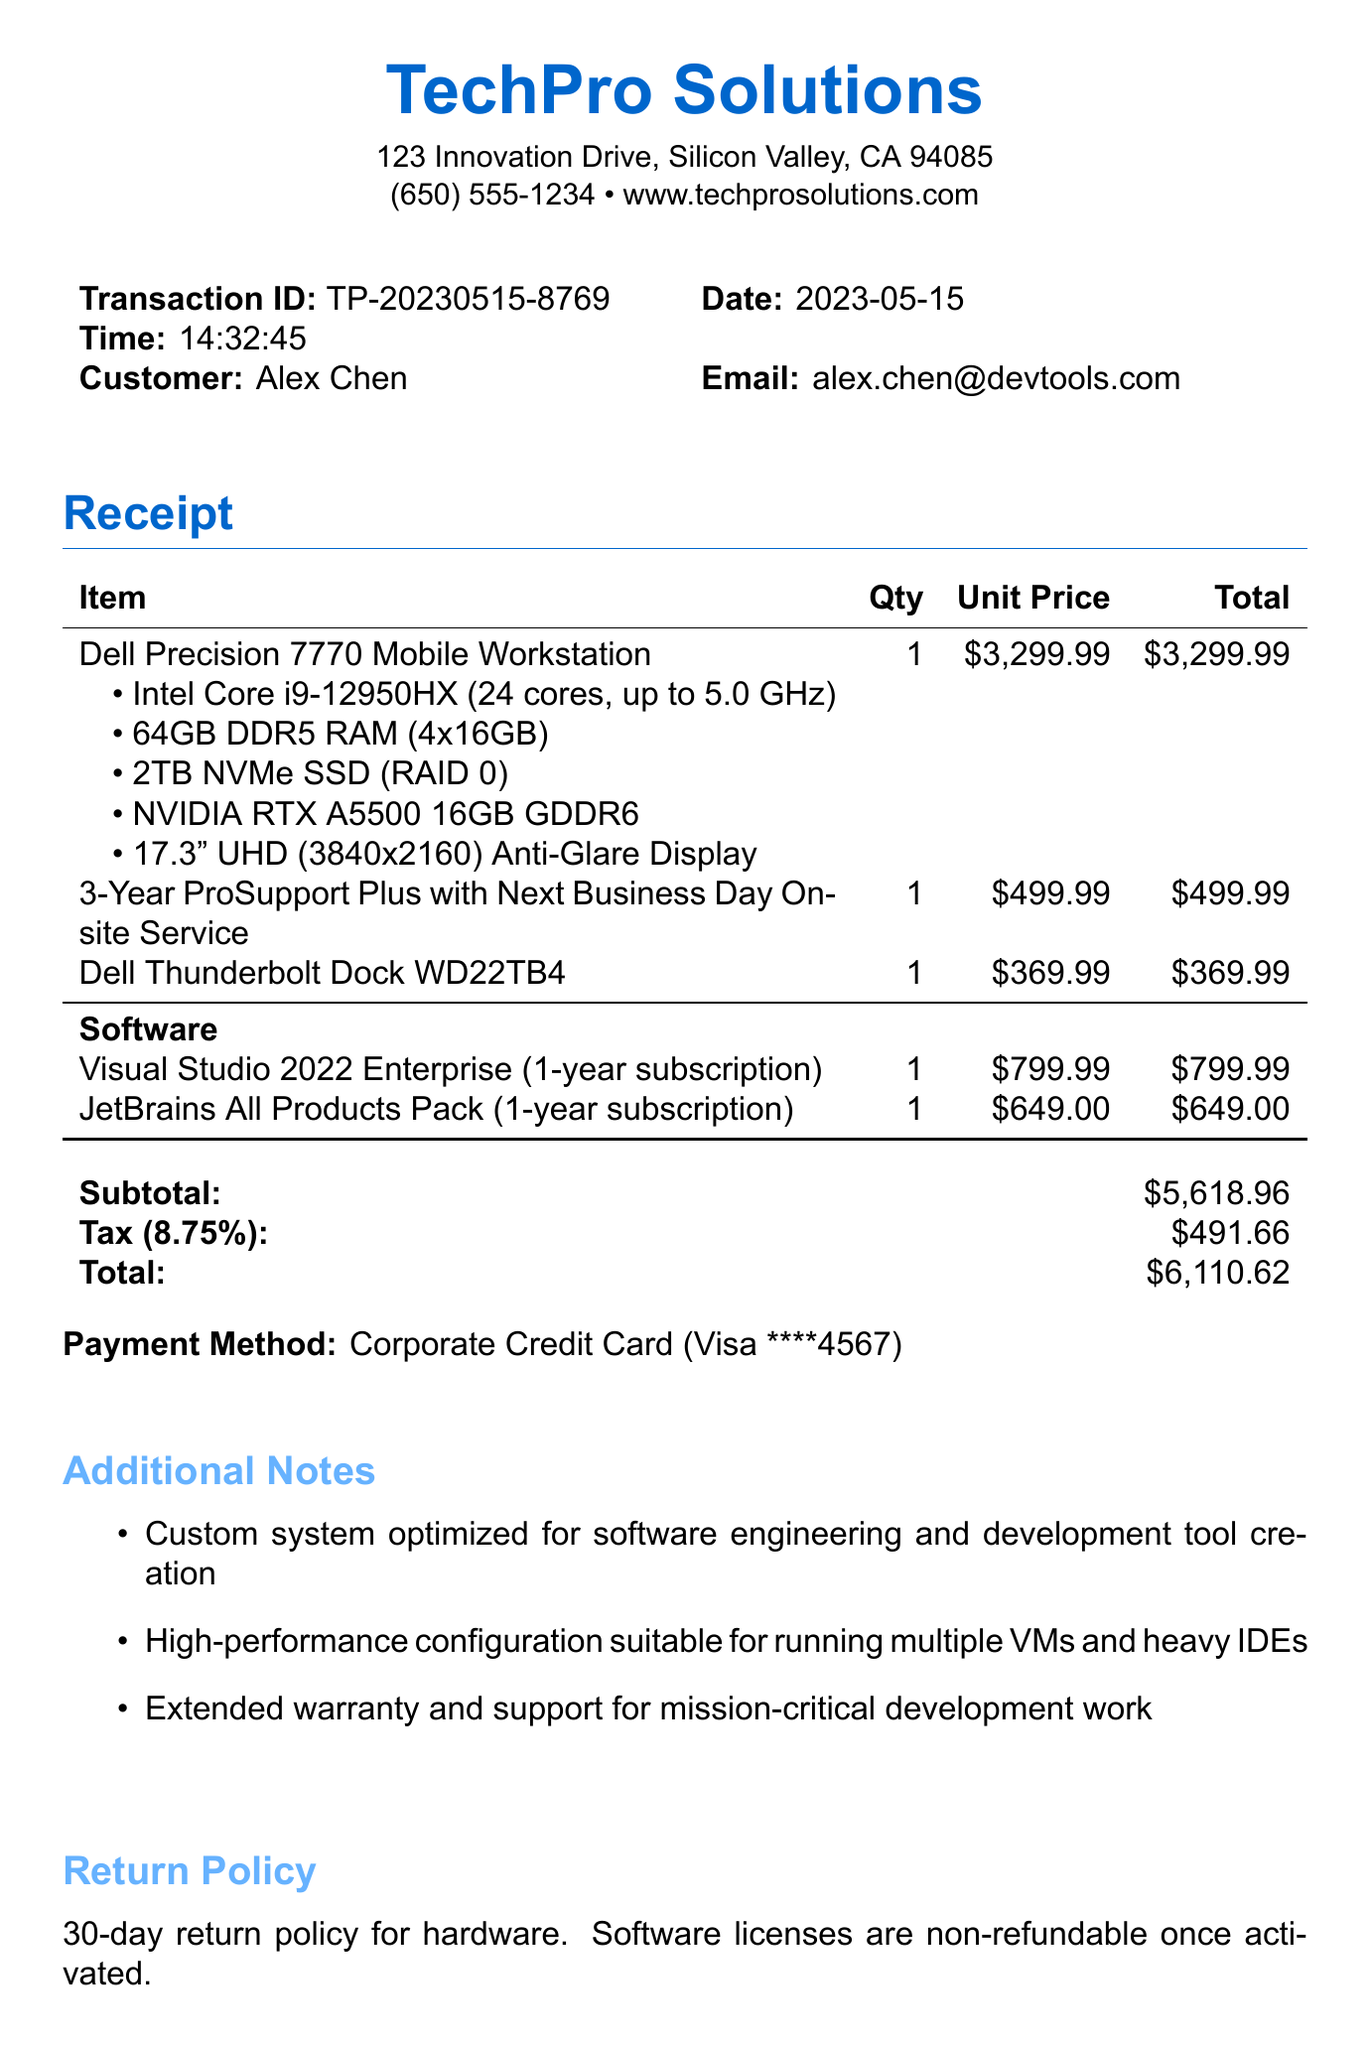What is the store name? The store name is provided at the top of the receipt as the main heading.
Answer: TechPro Solutions What is the total amount paid? The total amount paid is displayed at the bottom of the receipt after calculating the subtotal and tax.
Answer: $6,110.62 What is the transaction ID? The transaction ID is listed under the customer information section, identifying the specific transaction.
Answer: TP-20230515-8769 Who is the customer? The customer information includes the name of the individual who made the purchase.
Answer: Alex Chen How many customizations does the laptop have? The number of customizations for the laptop is counted from the list provided under the item description.
Answer: 5 What software subscriptions were purchased? The software subscriptions are listed in the receipt and represent additional items included in the purchase.
Answer: Visual Studio 2022 Enterprise, JetBrains All Products Pack What is the tax rate applied? The tax rate is indicated next to the tax amount and is a percentage of the subtotal.
Answer: 8.75% What is the return policy for hardware? The return policy shows the conditions under which a customer can return hardware.
Answer: 30-day return policy for hardware What additional service was included with the purchase? The additional service is mentioned as part of the items providing extended support.
Answer: 3-Year ProSupport Plus with Next Business Day Onsite Service 